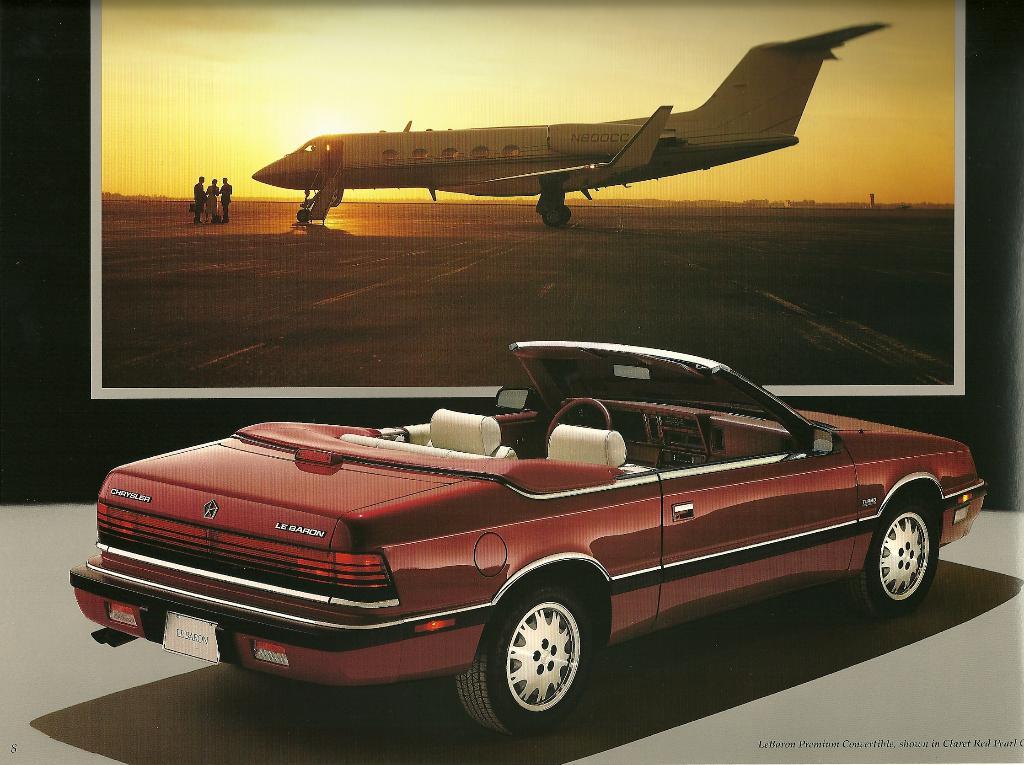What brand of car?
Keep it short and to the point. Crysler. 